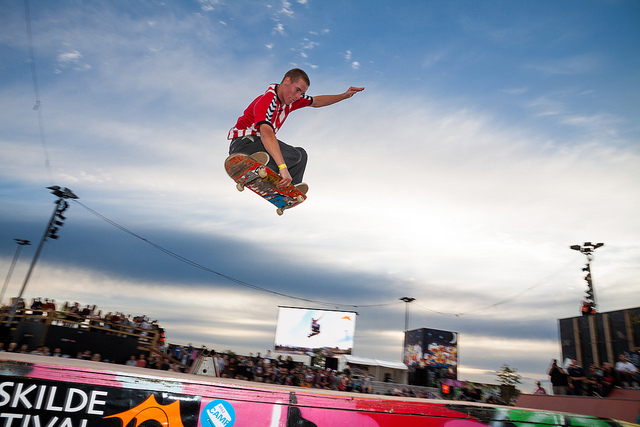Describe the atmosphere in the image. The atmosphere in the image seems electrifying and full of energy. The crowd is watching attentively, suggesting anticipation and excitement. The sky and lights hint at an outdoor event held around sunset, adding a dynamic and cheerful vibe to the scene. What other sports or activities could be happening in such an event? At such a large festival, there could be various sports and activities other than skateboarding. These might include BMX biking events, live music performances, food stalls, art exhibitions, and perhaps extreme sports demonstrations like freestyle motocross or parkour exhibitions. The diverse activities attract a wide range of spectators and participants, creating a vibrant and inclusive environment. Imagine if the skateboarder in the image were performing on the moon. What would be different? If the skateboarder in the image were performing on the moon, the trick would look quite different due to the moon's lower gravity. The jumps would be much higher and slower, giving the skater more airtime to perform complex tricks. They'd need a special suit to survive the harsh lunar conditions, and their skateboard might be modified to handle the moon's rocky terrain. The crowd would be replaced by Earth seen in the distance, and instead of an electric festival atmosphere, there'd be a serene, otherworldly silence. 